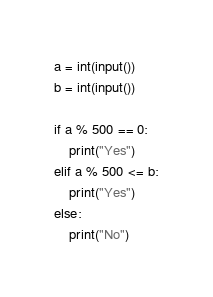<code> <loc_0><loc_0><loc_500><loc_500><_Python_>a = int(input())
b = int(input())

if a % 500 == 0:
    print("Yes")
elif a % 500 <= b:
    print("Yes")
else:
    print("No")
</code> 